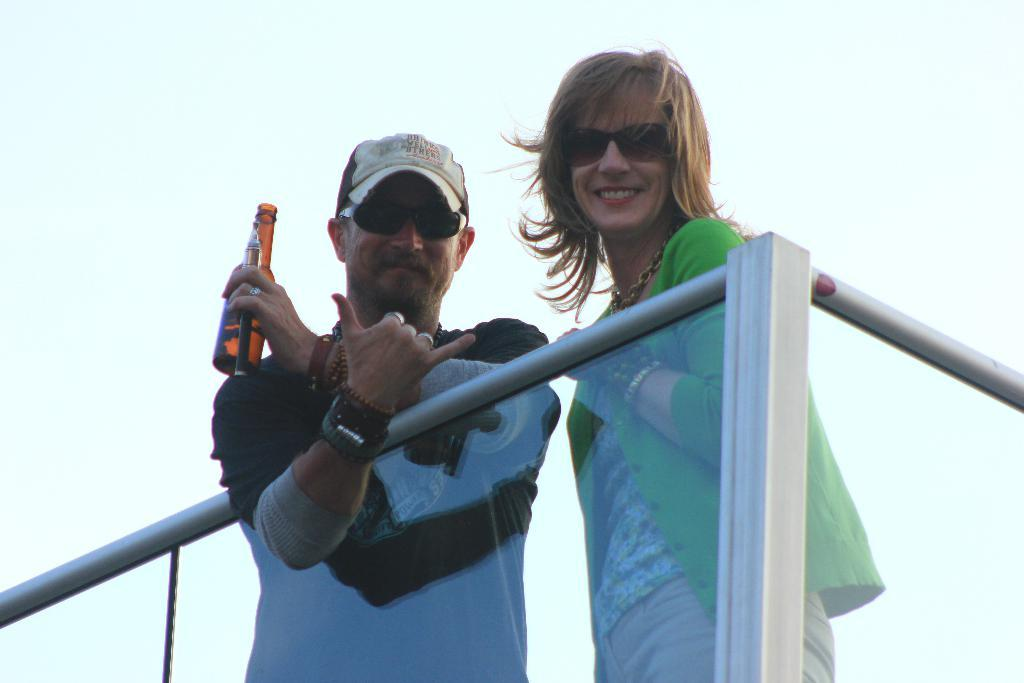What can be seen in the image that might be used for support or safety? There is railing in the image that can be used for support or safety. What are the two people wearing in the image? The two people are wearing goggles in the image. What is the facial expression of the two people? The two people are smiling in the image. What position are the two people in? The two people are standing in the image. What is the man holding in his hand? The man is holding a bottle in his hand. What can be seen in the distance in the image? The sky is visible in the background of the image. Can you see any combs in the mouth of the people in the image? There are no combs visible in the mouth of the people in the image. Are there any ants crawling on the railing in the image? There are no ants present in the image. 